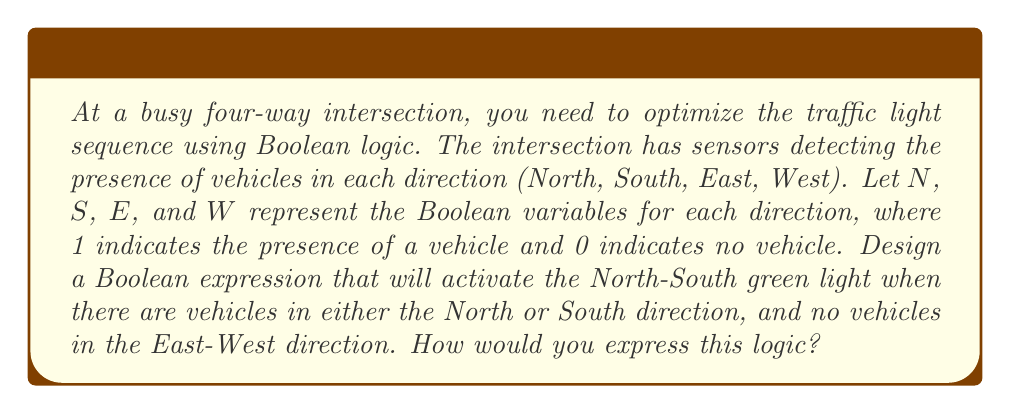Teach me how to tackle this problem. To solve this problem, we need to break it down into logical steps using Boolean algebra:

1. We want the North-South green light to activate when:
   - There are vehicles in either the North OR South direction, AND
   - There are NO vehicles in either the East OR West direction

2. Let's express each condition:
   - Vehicles in North OR South: $N \lor S$
   - NO vehicles in East AND West: $\overline{E} \land \overline{W}$

3. We need to combine these conditions using AND:
   $(N \lor S) \land (\overline{E} \land \overline{W})$

4. This expression can be simplified using the distributive property:
   $(N \land \overline{E} \land \overline{W}) \lor (S \land \overline{E} \land \overline{W})$

5. This Boolean expression will evaluate to 1 (true) only when:
   - There's a vehicle in the North OR South direction, AND
   - There are no vehicles in both East AND West directions

This logic ensures that the North-South green light is activated only when it's needed and safe to do so, optimizing traffic flow at the intersection.
Answer: $(N \lor S) \land (\overline{E} \land \overline{W})$ 